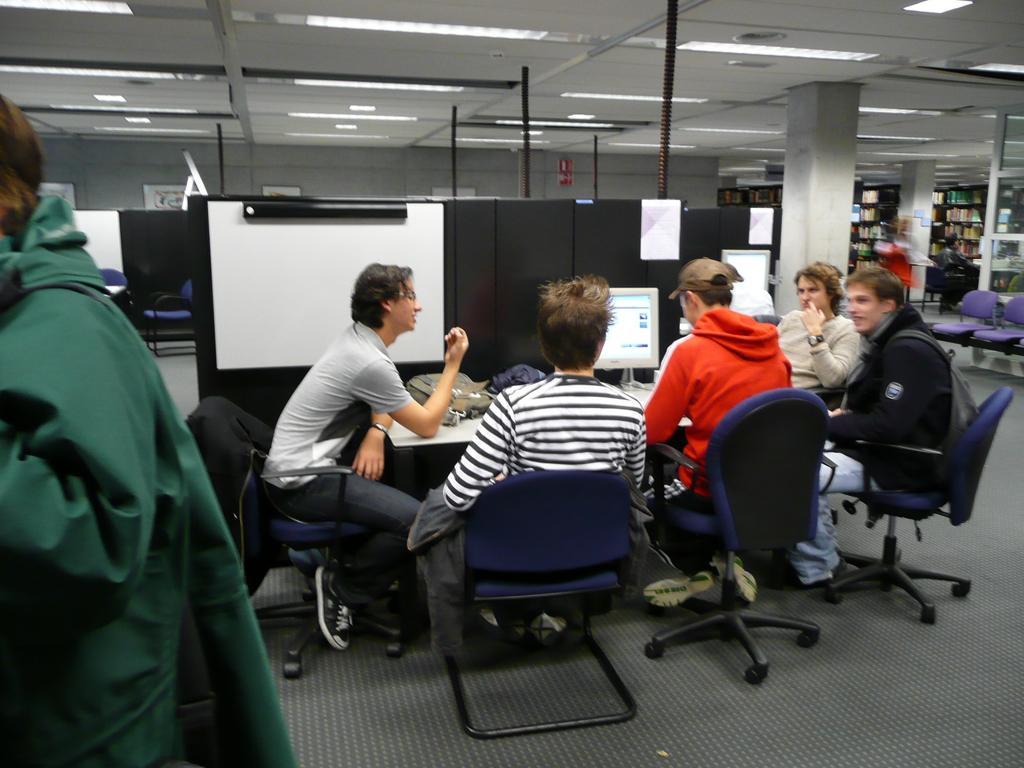Can you describe this image briefly? In the image we can see there are people who are sitting on chair and in front of them there is a monitor on the table and the man over here is wearing green colour jacket. 